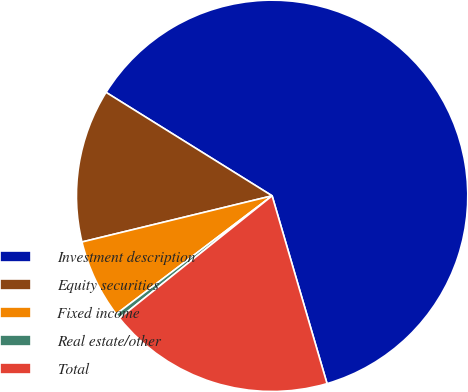Convert chart to OTSL. <chart><loc_0><loc_0><loc_500><loc_500><pie_chart><fcel>Investment description<fcel>Equity securities<fcel>Fixed income<fcel>Real estate/other<fcel>Total<nl><fcel>61.61%<fcel>12.66%<fcel>6.54%<fcel>0.42%<fcel>18.78%<nl></chart> 